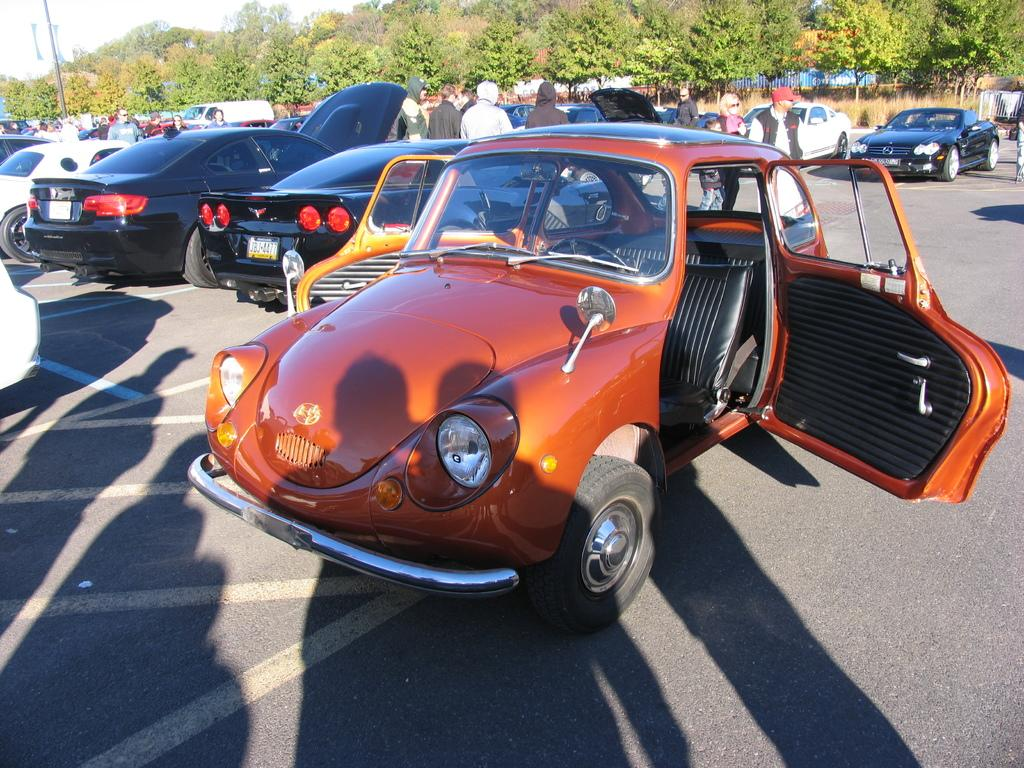What is happening on the road in the image? There are cars and people on the road in the image. What can be seen in the background of the image? There are trees, a pole, and the sky visible in the background of the image. Where is the basketball court located in the image? There is no basketball court present in the image. What level of detail can be seen in the image? The level of detail in the image cannot be determined from the provided facts. 